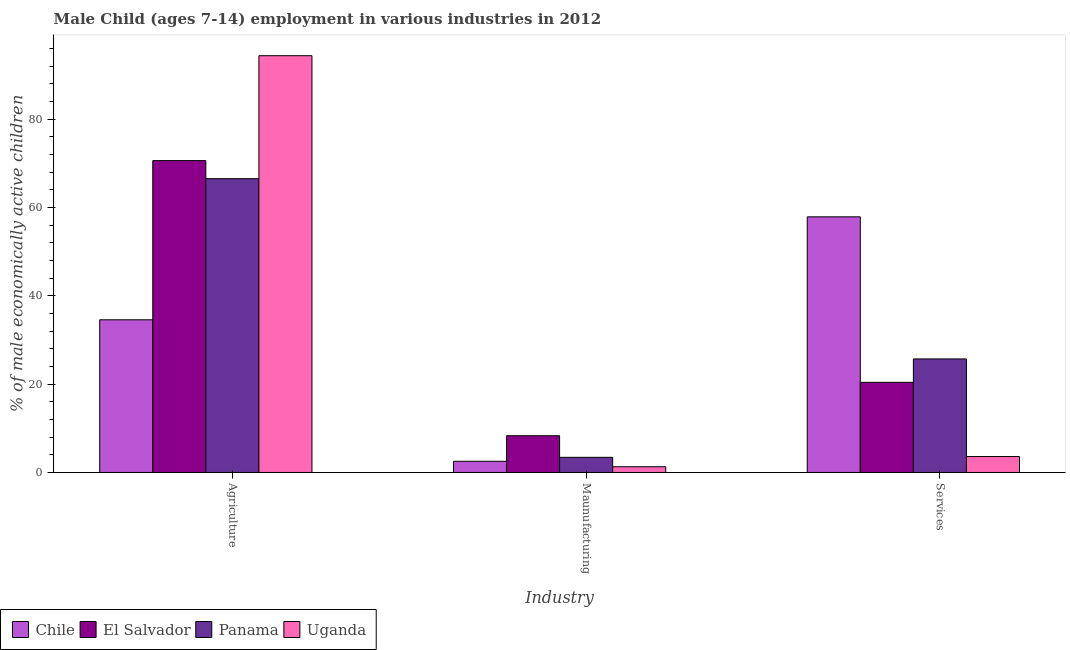How many bars are there on the 1st tick from the left?
Give a very brief answer. 4. How many bars are there on the 2nd tick from the right?
Your response must be concise. 4. What is the label of the 1st group of bars from the left?
Keep it short and to the point. Agriculture. What is the percentage of economically active children in manufacturing in El Salvador?
Offer a very short reply. 8.32. Across all countries, what is the maximum percentage of economically active children in services?
Make the answer very short. 57.88. Across all countries, what is the minimum percentage of economically active children in services?
Make the answer very short. 3.61. In which country was the percentage of economically active children in manufacturing maximum?
Provide a succinct answer. El Salvador. In which country was the percentage of economically active children in manufacturing minimum?
Make the answer very short. Uganda. What is the total percentage of economically active children in services in the graph?
Your answer should be very brief. 107.61. What is the difference between the percentage of economically active children in agriculture in El Salvador and that in Uganda?
Keep it short and to the point. -23.75. What is the difference between the percentage of economically active children in agriculture in Panama and the percentage of economically active children in manufacturing in Chile?
Give a very brief answer. 63.99. What is the average percentage of economically active children in manufacturing per country?
Your answer should be very brief. 3.9. What is the difference between the percentage of economically active children in services and percentage of economically active children in manufacturing in El Salvador?
Ensure brevity in your answer.  12.09. What is the ratio of the percentage of economically active children in services in El Salvador to that in Uganda?
Your answer should be compact. 5.65. Is the difference between the percentage of economically active children in manufacturing in Chile and Panama greater than the difference between the percentage of economically active children in agriculture in Chile and Panama?
Give a very brief answer. Yes. What is the difference between the highest and the second highest percentage of economically active children in agriculture?
Provide a succinct answer. 23.75. What is the difference between the highest and the lowest percentage of economically active children in agriculture?
Your response must be concise. 59.79. Is the sum of the percentage of economically active children in services in El Salvador and Chile greater than the maximum percentage of economically active children in agriculture across all countries?
Offer a terse response. No. What does the 3rd bar from the left in Agriculture represents?
Your response must be concise. Panama. What does the 2nd bar from the right in Maunufacturing represents?
Your answer should be compact. Panama. Is it the case that in every country, the sum of the percentage of economically active children in agriculture and percentage of economically active children in manufacturing is greater than the percentage of economically active children in services?
Keep it short and to the point. No. What is the difference between two consecutive major ticks on the Y-axis?
Provide a short and direct response. 20. Are the values on the major ticks of Y-axis written in scientific E-notation?
Your answer should be very brief. No. How are the legend labels stacked?
Offer a terse response. Horizontal. What is the title of the graph?
Provide a succinct answer. Male Child (ages 7-14) employment in various industries in 2012. Does "France" appear as one of the legend labels in the graph?
Offer a terse response. No. What is the label or title of the X-axis?
Offer a terse response. Industry. What is the label or title of the Y-axis?
Your answer should be very brief. % of male economically active children. What is the % of male economically active children of Chile in Agriculture?
Ensure brevity in your answer.  34.57. What is the % of male economically active children in El Salvador in Agriculture?
Keep it short and to the point. 70.61. What is the % of male economically active children of Panama in Agriculture?
Give a very brief answer. 66.52. What is the % of male economically active children in Uganda in Agriculture?
Provide a short and direct response. 94.36. What is the % of male economically active children of Chile in Maunufacturing?
Provide a succinct answer. 2.53. What is the % of male economically active children in El Salvador in Maunufacturing?
Provide a succinct answer. 8.32. What is the % of male economically active children in Panama in Maunufacturing?
Offer a very short reply. 3.43. What is the % of male economically active children in Uganda in Maunufacturing?
Offer a terse response. 1.3. What is the % of male economically active children in Chile in Services?
Offer a very short reply. 57.88. What is the % of male economically active children of El Salvador in Services?
Keep it short and to the point. 20.41. What is the % of male economically active children of Panama in Services?
Ensure brevity in your answer.  25.71. What is the % of male economically active children of Uganda in Services?
Offer a terse response. 3.61. Across all Industry, what is the maximum % of male economically active children in Chile?
Keep it short and to the point. 57.88. Across all Industry, what is the maximum % of male economically active children of El Salvador?
Your answer should be compact. 70.61. Across all Industry, what is the maximum % of male economically active children in Panama?
Make the answer very short. 66.52. Across all Industry, what is the maximum % of male economically active children in Uganda?
Provide a short and direct response. 94.36. Across all Industry, what is the minimum % of male economically active children in Chile?
Your answer should be very brief. 2.53. Across all Industry, what is the minimum % of male economically active children of El Salvador?
Keep it short and to the point. 8.32. Across all Industry, what is the minimum % of male economically active children of Panama?
Provide a short and direct response. 3.43. Across all Industry, what is the minimum % of male economically active children in Uganda?
Ensure brevity in your answer.  1.3. What is the total % of male economically active children of Chile in the graph?
Offer a terse response. 94.98. What is the total % of male economically active children in El Salvador in the graph?
Make the answer very short. 99.34. What is the total % of male economically active children of Panama in the graph?
Make the answer very short. 95.66. What is the total % of male economically active children in Uganda in the graph?
Make the answer very short. 99.27. What is the difference between the % of male economically active children in Chile in Agriculture and that in Maunufacturing?
Your answer should be very brief. 32.04. What is the difference between the % of male economically active children in El Salvador in Agriculture and that in Maunufacturing?
Your response must be concise. 62.29. What is the difference between the % of male economically active children of Panama in Agriculture and that in Maunufacturing?
Your response must be concise. 63.09. What is the difference between the % of male economically active children in Uganda in Agriculture and that in Maunufacturing?
Provide a succinct answer. 93.06. What is the difference between the % of male economically active children in Chile in Agriculture and that in Services?
Provide a short and direct response. -23.31. What is the difference between the % of male economically active children in El Salvador in Agriculture and that in Services?
Offer a terse response. 50.2. What is the difference between the % of male economically active children in Panama in Agriculture and that in Services?
Ensure brevity in your answer.  40.81. What is the difference between the % of male economically active children in Uganda in Agriculture and that in Services?
Provide a short and direct response. 90.75. What is the difference between the % of male economically active children of Chile in Maunufacturing and that in Services?
Your answer should be compact. -55.35. What is the difference between the % of male economically active children in El Salvador in Maunufacturing and that in Services?
Give a very brief answer. -12.09. What is the difference between the % of male economically active children in Panama in Maunufacturing and that in Services?
Your answer should be very brief. -22.28. What is the difference between the % of male economically active children in Uganda in Maunufacturing and that in Services?
Keep it short and to the point. -2.31. What is the difference between the % of male economically active children of Chile in Agriculture and the % of male economically active children of El Salvador in Maunufacturing?
Ensure brevity in your answer.  26.25. What is the difference between the % of male economically active children of Chile in Agriculture and the % of male economically active children of Panama in Maunufacturing?
Provide a short and direct response. 31.14. What is the difference between the % of male economically active children of Chile in Agriculture and the % of male economically active children of Uganda in Maunufacturing?
Give a very brief answer. 33.27. What is the difference between the % of male economically active children in El Salvador in Agriculture and the % of male economically active children in Panama in Maunufacturing?
Offer a very short reply. 67.18. What is the difference between the % of male economically active children in El Salvador in Agriculture and the % of male economically active children in Uganda in Maunufacturing?
Offer a very short reply. 69.31. What is the difference between the % of male economically active children in Panama in Agriculture and the % of male economically active children in Uganda in Maunufacturing?
Keep it short and to the point. 65.22. What is the difference between the % of male economically active children in Chile in Agriculture and the % of male economically active children in El Salvador in Services?
Ensure brevity in your answer.  14.16. What is the difference between the % of male economically active children of Chile in Agriculture and the % of male economically active children of Panama in Services?
Offer a terse response. 8.86. What is the difference between the % of male economically active children of Chile in Agriculture and the % of male economically active children of Uganda in Services?
Keep it short and to the point. 30.96. What is the difference between the % of male economically active children of El Salvador in Agriculture and the % of male economically active children of Panama in Services?
Ensure brevity in your answer.  44.9. What is the difference between the % of male economically active children in Panama in Agriculture and the % of male economically active children in Uganda in Services?
Keep it short and to the point. 62.91. What is the difference between the % of male economically active children in Chile in Maunufacturing and the % of male economically active children in El Salvador in Services?
Your answer should be very brief. -17.88. What is the difference between the % of male economically active children of Chile in Maunufacturing and the % of male economically active children of Panama in Services?
Your answer should be very brief. -23.18. What is the difference between the % of male economically active children of Chile in Maunufacturing and the % of male economically active children of Uganda in Services?
Keep it short and to the point. -1.08. What is the difference between the % of male economically active children in El Salvador in Maunufacturing and the % of male economically active children in Panama in Services?
Offer a very short reply. -17.39. What is the difference between the % of male economically active children of El Salvador in Maunufacturing and the % of male economically active children of Uganda in Services?
Give a very brief answer. 4.71. What is the difference between the % of male economically active children in Panama in Maunufacturing and the % of male economically active children in Uganda in Services?
Offer a very short reply. -0.18. What is the average % of male economically active children of Chile per Industry?
Your answer should be compact. 31.66. What is the average % of male economically active children in El Salvador per Industry?
Make the answer very short. 33.11. What is the average % of male economically active children in Panama per Industry?
Offer a very short reply. 31.89. What is the average % of male economically active children of Uganda per Industry?
Your answer should be compact. 33.09. What is the difference between the % of male economically active children in Chile and % of male economically active children in El Salvador in Agriculture?
Provide a short and direct response. -36.04. What is the difference between the % of male economically active children in Chile and % of male economically active children in Panama in Agriculture?
Make the answer very short. -31.95. What is the difference between the % of male economically active children in Chile and % of male economically active children in Uganda in Agriculture?
Give a very brief answer. -59.79. What is the difference between the % of male economically active children in El Salvador and % of male economically active children in Panama in Agriculture?
Your answer should be very brief. 4.09. What is the difference between the % of male economically active children of El Salvador and % of male economically active children of Uganda in Agriculture?
Provide a short and direct response. -23.75. What is the difference between the % of male economically active children of Panama and % of male economically active children of Uganda in Agriculture?
Offer a very short reply. -27.84. What is the difference between the % of male economically active children of Chile and % of male economically active children of El Salvador in Maunufacturing?
Ensure brevity in your answer.  -5.79. What is the difference between the % of male economically active children in Chile and % of male economically active children in Panama in Maunufacturing?
Offer a very short reply. -0.9. What is the difference between the % of male economically active children of Chile and % of male economically active children of Uganda in Maunufacturing?
Ensure brevity in your answer.  1.23. What is the difference between the % of male economically active children of El Salvador and % of male economically active children of Panama in Maunufacturing?
Provide a succinct answer. 4.89. What is the difference between the % of male economically active children in El Salvador and % of male economically active children in Uganda in Maunufacturing?
Your answer should be compact. 7.02. What is the difference between the % of male economically active children of Panama and % of male economically active children of Uganda in Maunufacturing?
Give a very brief answer. 2.13. What is the difference between the % of male economically active children of Chile and % of male economically active children of El Salvador in Services?
Ensure brevity in your answer.  37.47. What is the difference between the % of male economically active children in Chile and % of male economically active children in Panama in Services?
Your answer should be very brief. 32.17. What is the difference between the % of male economically active children in Chile and % of male economically active children in Uganda in Services?
Your answer should be very brief. 54.27. What is the difference between the % of male economically active children of El Salvador and % of male economically active children of Panama in Services?
Your answer should be compact. -5.3. What is the difference between the % of male economically active children of El Salvador and % of male economically active children of Uganda in Services?
Keep it short and to the point. 16.8. What is the difference between the % of male economically active children in Panama and % of male economically active children in Uganda in Services?
Give a very brief answer. 22.1. What is the ratio of the % of male economically active children of Chile in Agriculture to that in Maunufacturing?
Offer a very short reply. 13.66. What is the ratio of the % of male economically active children in El Salvador in Agriculture to that in Maunufacturing?
Give a very brief answer. 8.49. What is the ratio of the % of male economically active children in Panama in Agriculture to that in Maunufacturing?
Ensure brevity in your answer.  19.39. What is the ratio of the % of male economically active children in Uganda in Agriculture to that in Maunufacturing?
Ensure brevity in your answer.  72.58. What is the ratio of the % of male economically active children of Chile in Agriculture to that in Services?
Give a very brief answer. 0.6. What is the ratio of the % of male economically active children in El Salvador in Agriculture to that in Services?
Your answer should be compact. 3.46. What is the ratio of the % of male economically active children in Panama in Agriculture to that in Services?
Your answer should be compact. 2.59. What is the ratio of the % of male economically active children in Uganda in Agriculture to that in Services?
Offer a terse response. 26.14. What is the ratio of the % of male economically active children in Chile in Maunufacturing to that in Services?
Give a very brief answer. 0.04. What is the ratio of the % of male economically active children in El Salvador in Maunufacturing to that in Services?
Your answer should be very brief. 0.41. What is the ratio of the % of male economically active children of Panama in Maunufacturing to that in Services?
Ensure brevity in your answer.  0.13. What is the ratio of the % of male economically active children in Uganda in Maunufacturing to that in Services?
Provide a succinct answer. 0.36. What is the difference between the highest and the second highest % of male economically active children of Chile?
Keep it short and to the point. 23.31. What is the difference between the highest and the second highest % of male economically active children in El Salvador?
Give a very brief answer. 50.2. What is the difference between the highest and the second highest % of male economically active children in Panama?
Provide a succinct answer. 40.81. What is the difference between the highest and the second highest % of male economically active children of Uganda?
Give a very brief answer. 90.75. What is the difference between the highest and the lowest % of male economically active children in Chile?
Provide a succinct answer. 55.35. What is the difference between the highest and the lowest % of male economically active children of El Salvador?
Your answer should be very brief. 62.29. What is the difference between the highest and the lowest % of male economically active children in Panama?
Your response must be concise. 63.09. What is the difference between the highest and the lowest % of male economically active children of Uganda?
Your answer should be compact. 93.06. 